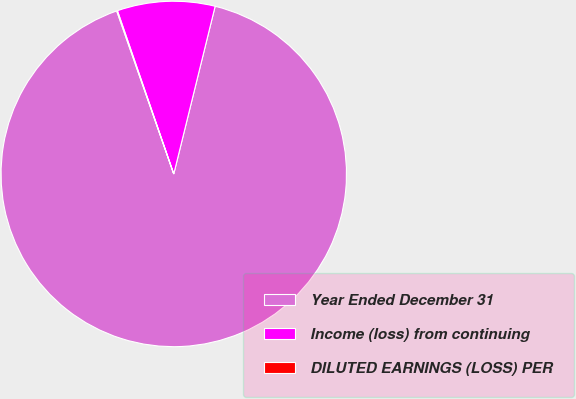Convert chart to OTSL. <chart><loc_0><loc_0><loc_500><loc_500><pie_chart><fcel>Year Ended December 31<fcel>Income (loss) from continuing<fcel>DILUTED EARNINGS (LOSS) PER<nl><fcel>90.79%<fcel>9.14%<fcel>0.07%<nl></chart> 